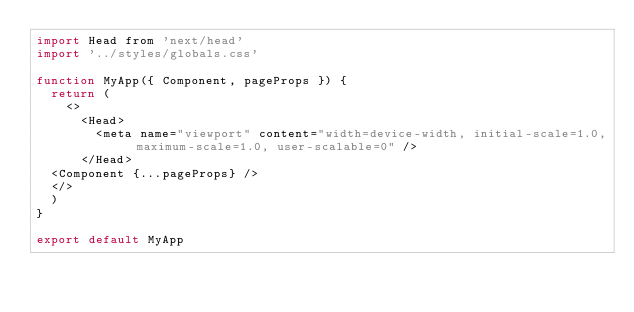<code> <loc_0><loc_0><loc_500><loc_500><_JavaScript_>import Head from 'next/head'
import '../styles/globals.css'

function MyApp({ Component, pageProps }) {
  return (
    <>
      <Head>
        <meta name="viewport" content="width=device-width, initial-scale=1.0, maximum-scale=1.0, user-scalable=0" />
      </Head>
  <Component {...pageProps} />
  </>
  )
}

export default MyApp
</code> 